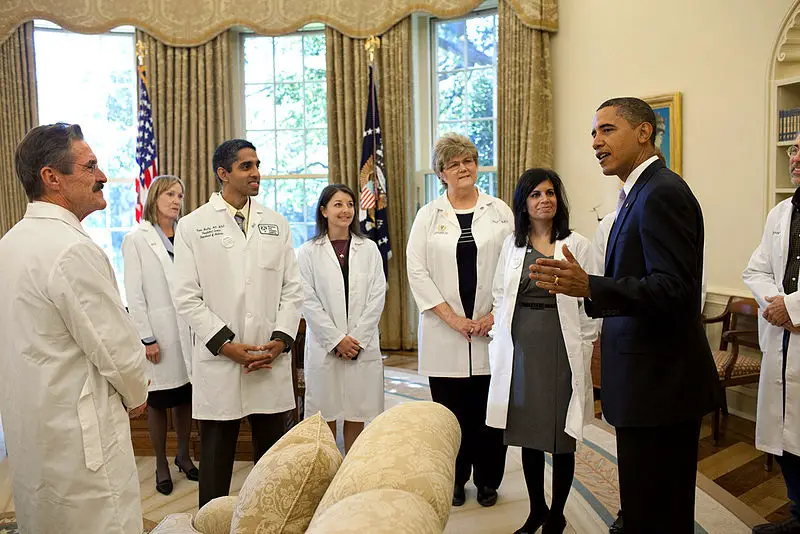Considering the attire of the individuals and the decor of the room, what type of event or meeting might this image depict, and what roles do the individuals in white coats represent? This image appears to be taken during a formal meeting, possibly in a governmental or official setting, such as a presidential office or a high-level briefing room. The elegant decor and the presence of an individual in a suit suggest a discussion of substantial importance. The individuals wearing white coats, bearing name badges, are likely medical professionals or scientists. Given their attire and the evident engagement with the individual in the suit, it's plausible that the discussion revolves around healthcare or scientific issues of significant national interest. 